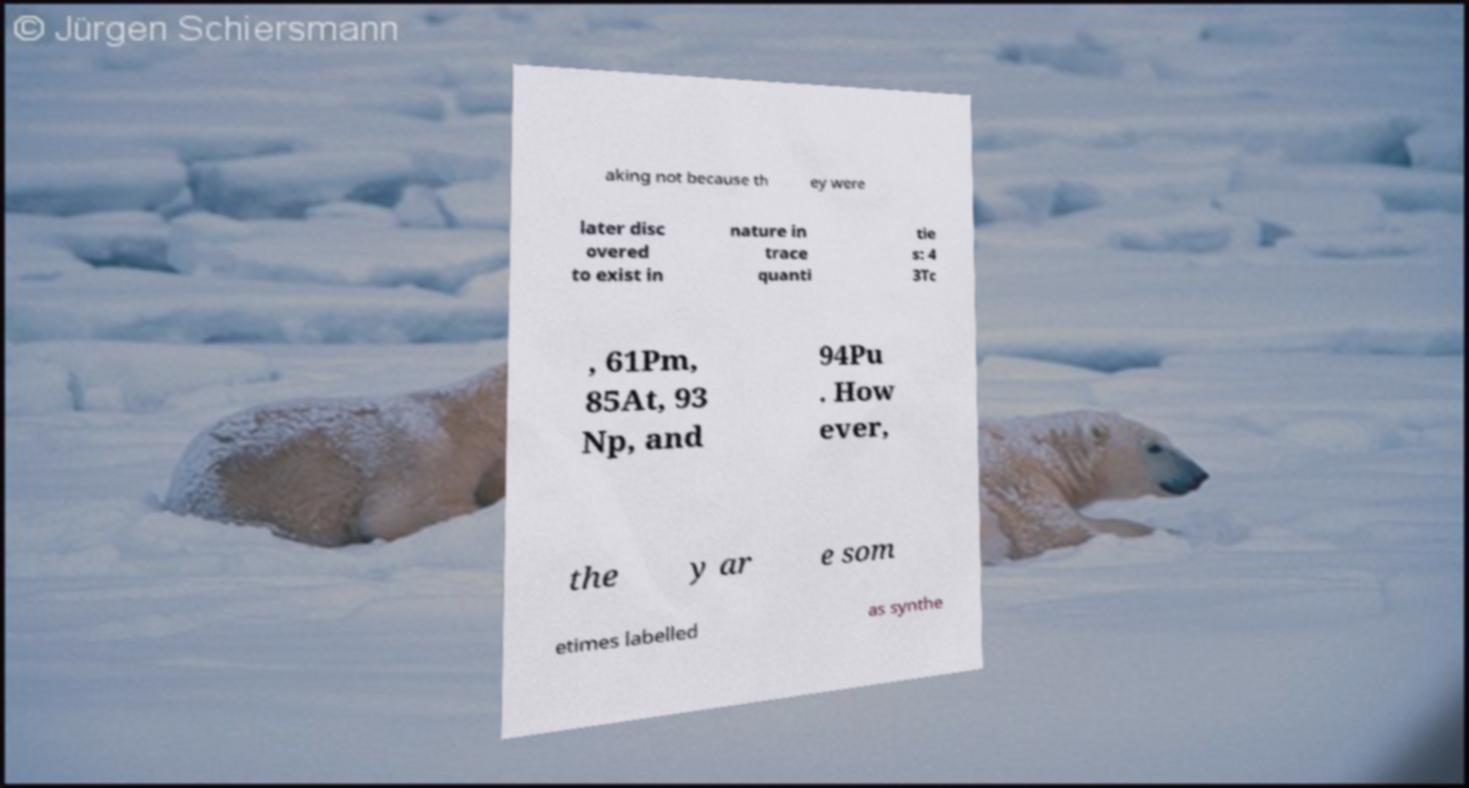Could you assist in decoding the text presented in this image and type it out clearly? aking not because th ey were later disc overed to exist in nature in trace quanti tie s: 4 3Tc , 61Pm, 85At, 93 Np, and 94Pu . How ever, the y ar e som etimes labelled as synthe 